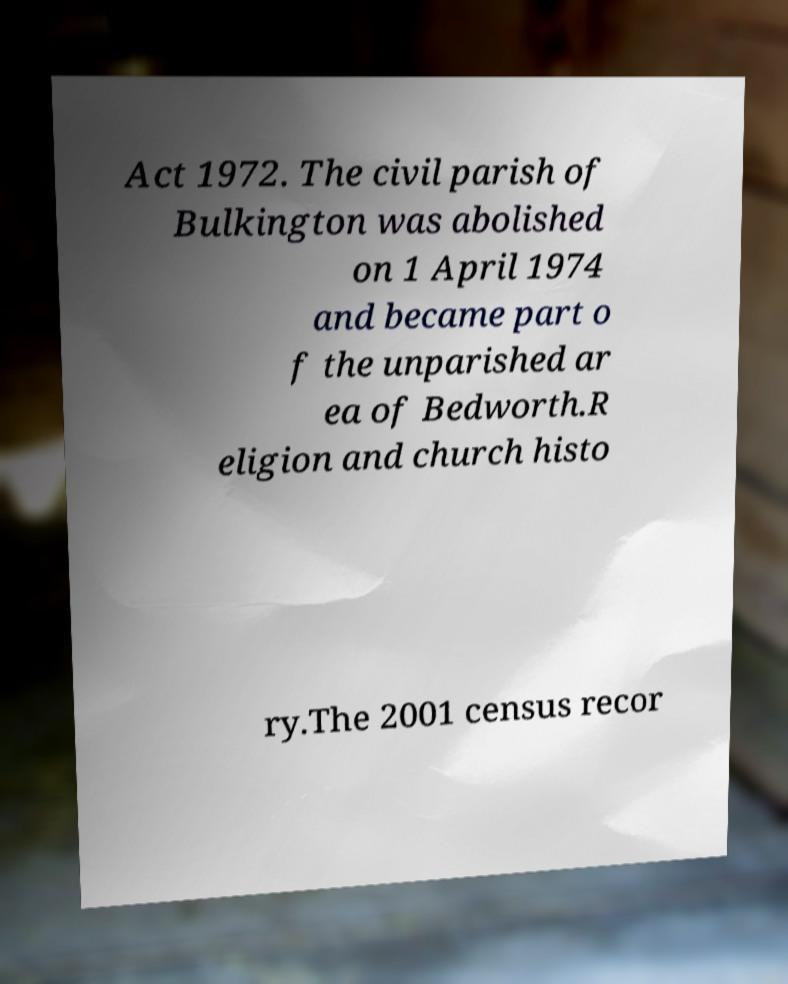Could you assist in decoding the text presented in this image and type it out clearly? Act 1972. The civil parish of Bulkington was abolished on 1 April 1974 and became part o f the unparished ar ea of Bedworth.R eligion and church histo ry.The 2001 census recor 